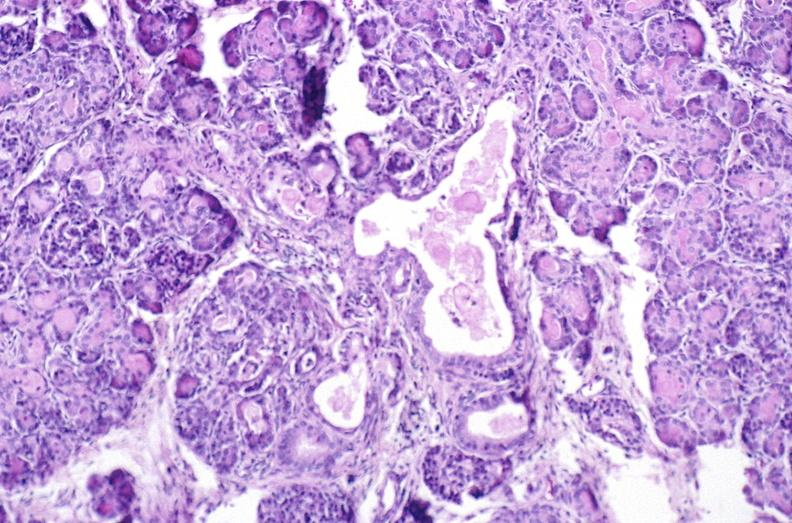where is this?
Answer the question using a single word or phrase. Pancreas 